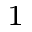Convert formula to latex. <formula><loc_0><loc_0><loc_500><loc_500>^ { 1 }</formula> 